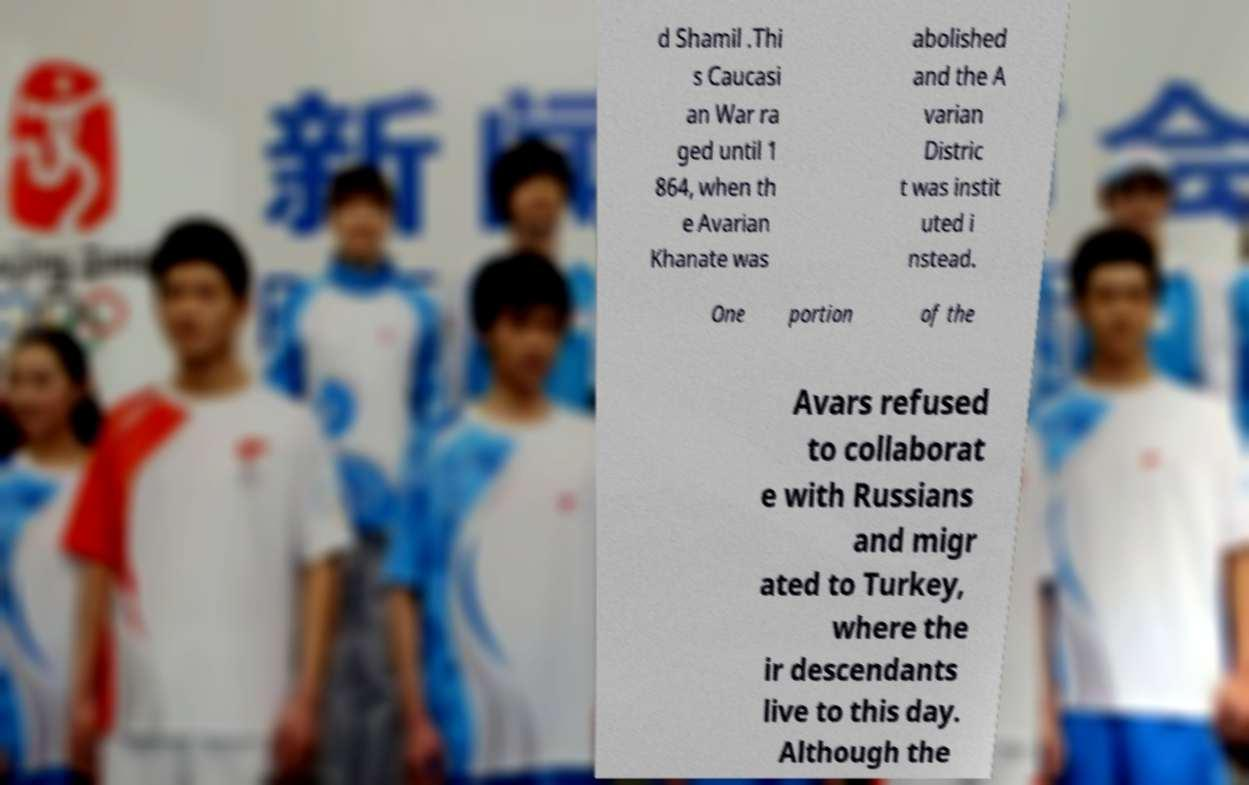For documentation purposes, I need the text within this image transcribed. Could you provide that? d Shamil .Thi s Caucasi an War ra ged until 1 864, when th e Avarian Khanate was abolished and the A varian Distric t was instit uted i nstead. One portion of the Avars refused to collaborat e with Russians and migr ated to Turkey, where the ir descendants live to this day. Although the 